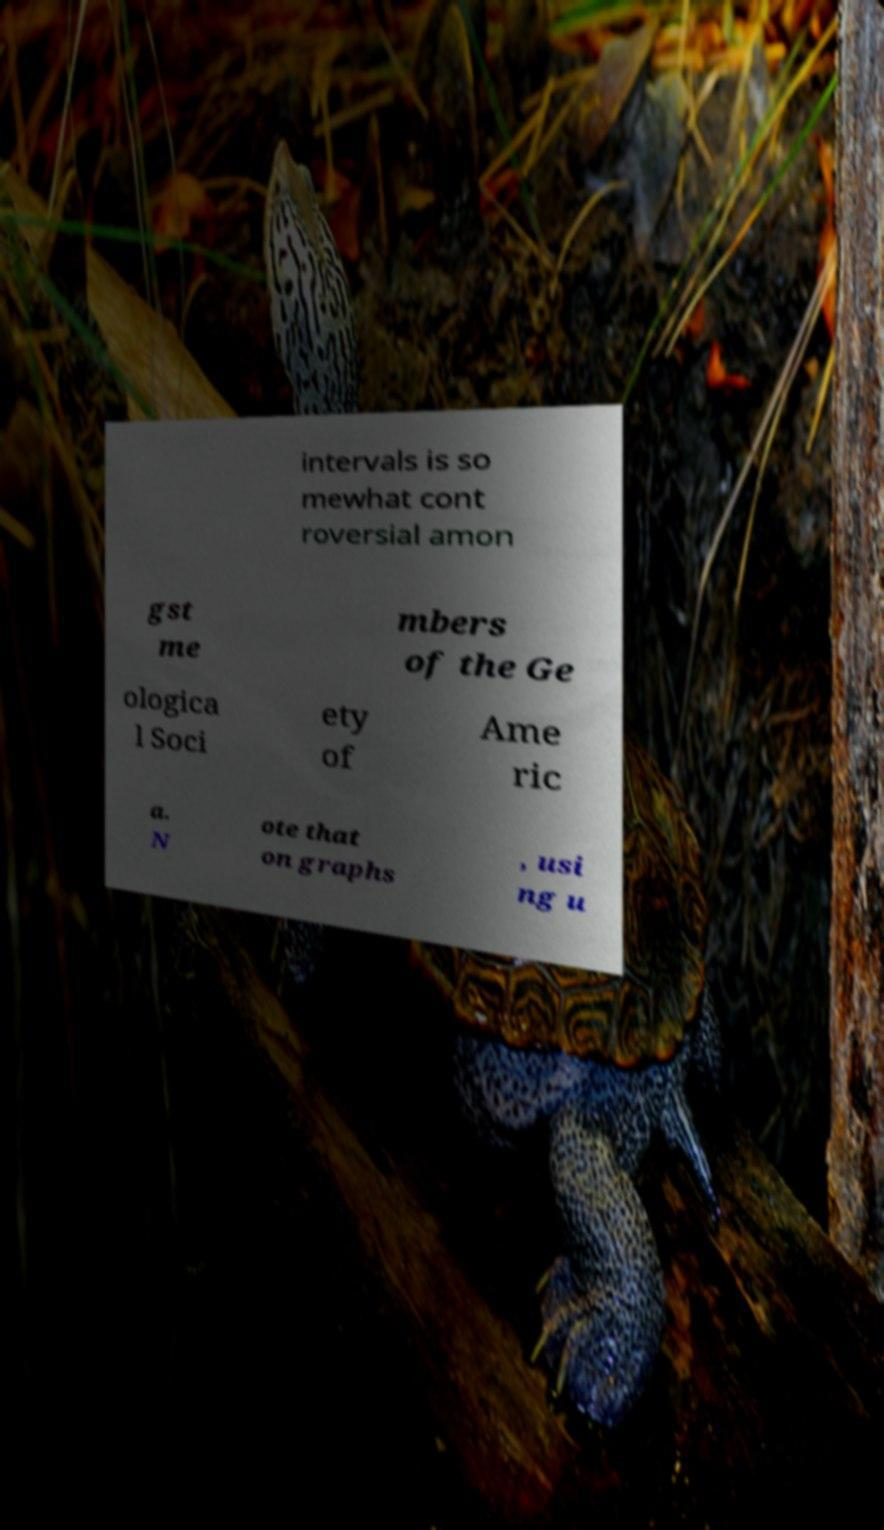There's text embedded in this image that I need extracted. Can you transcribe it verbatim? intervals is so mewhat cont roversial amon gst me mbers of the Ge ologica l Soci ety of Ame ric a. N ote that on graphs , usi ng u 